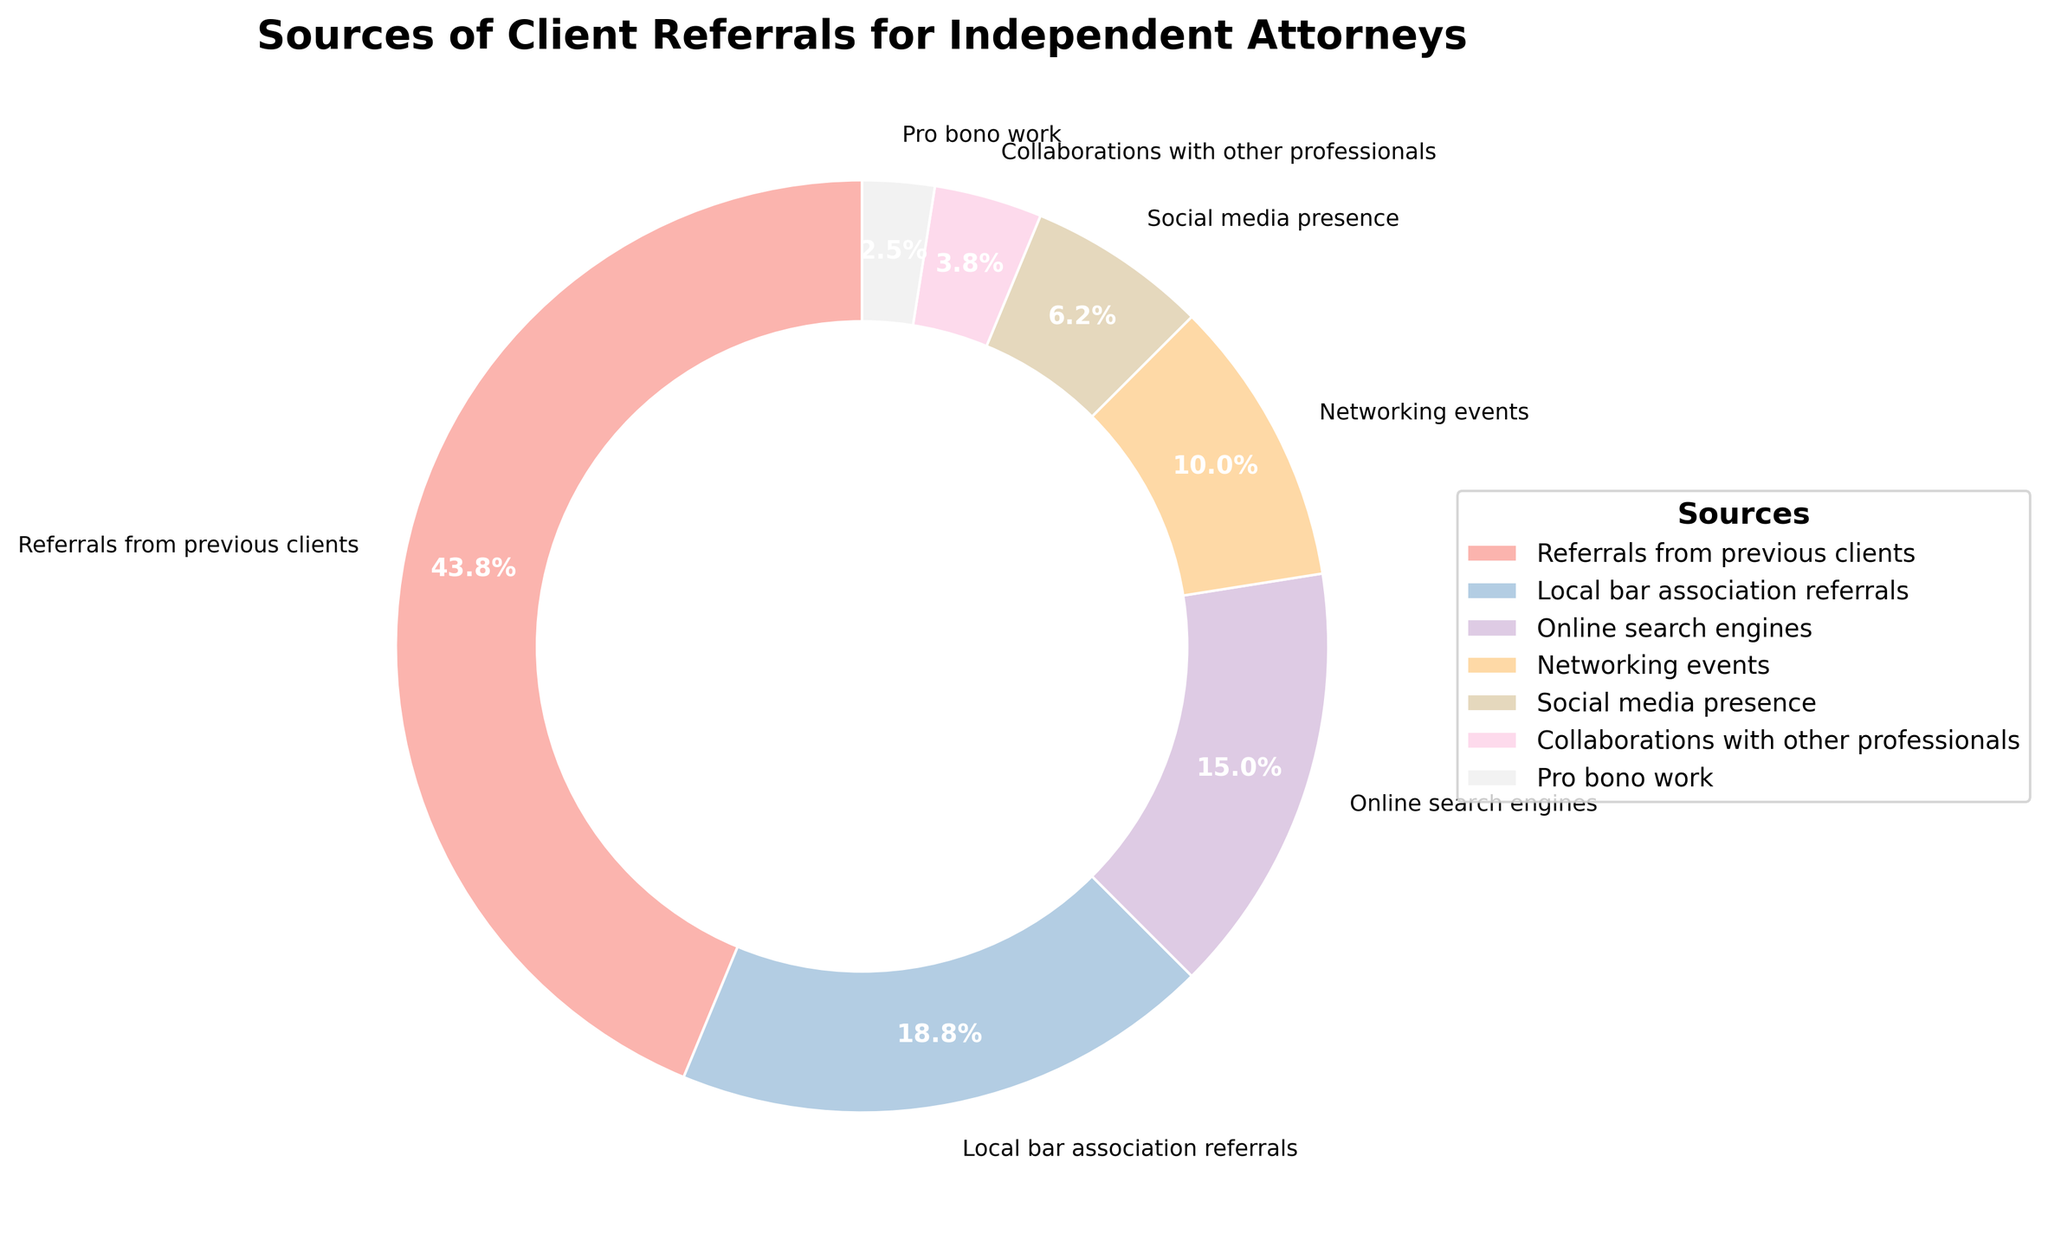Which source of referrals has the highest percentage? The chart shows that "Referrals from previous clients" has the largest wedge, corresponding to 35%.
Answer: Referrals from previous clients What two sources combined make up 20% of the referrals? From the chart, "Social media presence" is 5% and "Networking events" is 8%, totaling 13%; instead, "Local bar association referrals" is 15% and "Pro bono work" is 2%, totaling 17%. The combination of "Social media presence" (5%) and "Collaborations with other professionals" (3%) sums up to 8%. The correct combination is "Online search engines" (12%) and "Pro bono work" (8%) making up 20%.
Answer: Online search engines and Pro bono work Which category contributes the least to client referrals? The wedge for "Pro bono work" is the smallest on the chart and corresponds to 2%.
Answer: Pro bono work Are referrals from previous clients greater than the total of online sources (Online search engines + Social media presence)? The sum of "Online search engines" (12%) and "Social media presence" (5%) is 17%. "Referrals from previous clients" is 35%, which is greater than 17%.
Answer: Yes How much more significant are referrals from previous clients compared to those from networking events? To find the difference, subtract the percentage for "Networking events" from "Referrals from previous clients": 35% - 8% = 27%.
Answer: 27% What is the combined percentage of referrals from local bar association referrals and collaborations with other professionals? Add the percentages of "Local bar association referrals" (15%) and "Collaborations with other professionals" (3%): 15% + 3% = 18%.
Answer: 18% Are networking events contributing more than social media presence? The chart shows "Networking events" at 8% and "Social media presence" at 5%. Since 8% is more than 5%, networking events contribute more.
Answer: Yes What is the percentage difference between local bar association referrals and social media presence? Subtract the percentage of "Social media presence" (5%) from "Local bar association referrals" (15%): 15% - 5% = 10%.
Answer: 10% By how much does the percentage of referrals from previous clients exceed that of local bar association referrals? Subtract the percentage of "Local bar association referrals" (15%) from "Referrals from previous clients" (35%): 35% - 15% = 20%.
Answer: 20% What is the total percentage for all sources contributing less than 10% individually? Add the percentages of each source contributing less than 10%: "Networking events" (8%), "Social media presence" (5%), "Collaborations with other professionals" (3%), and "Pro bono work" (2%): 8% + 5% + 3% + 2% = 18%.
Answer: 18% 